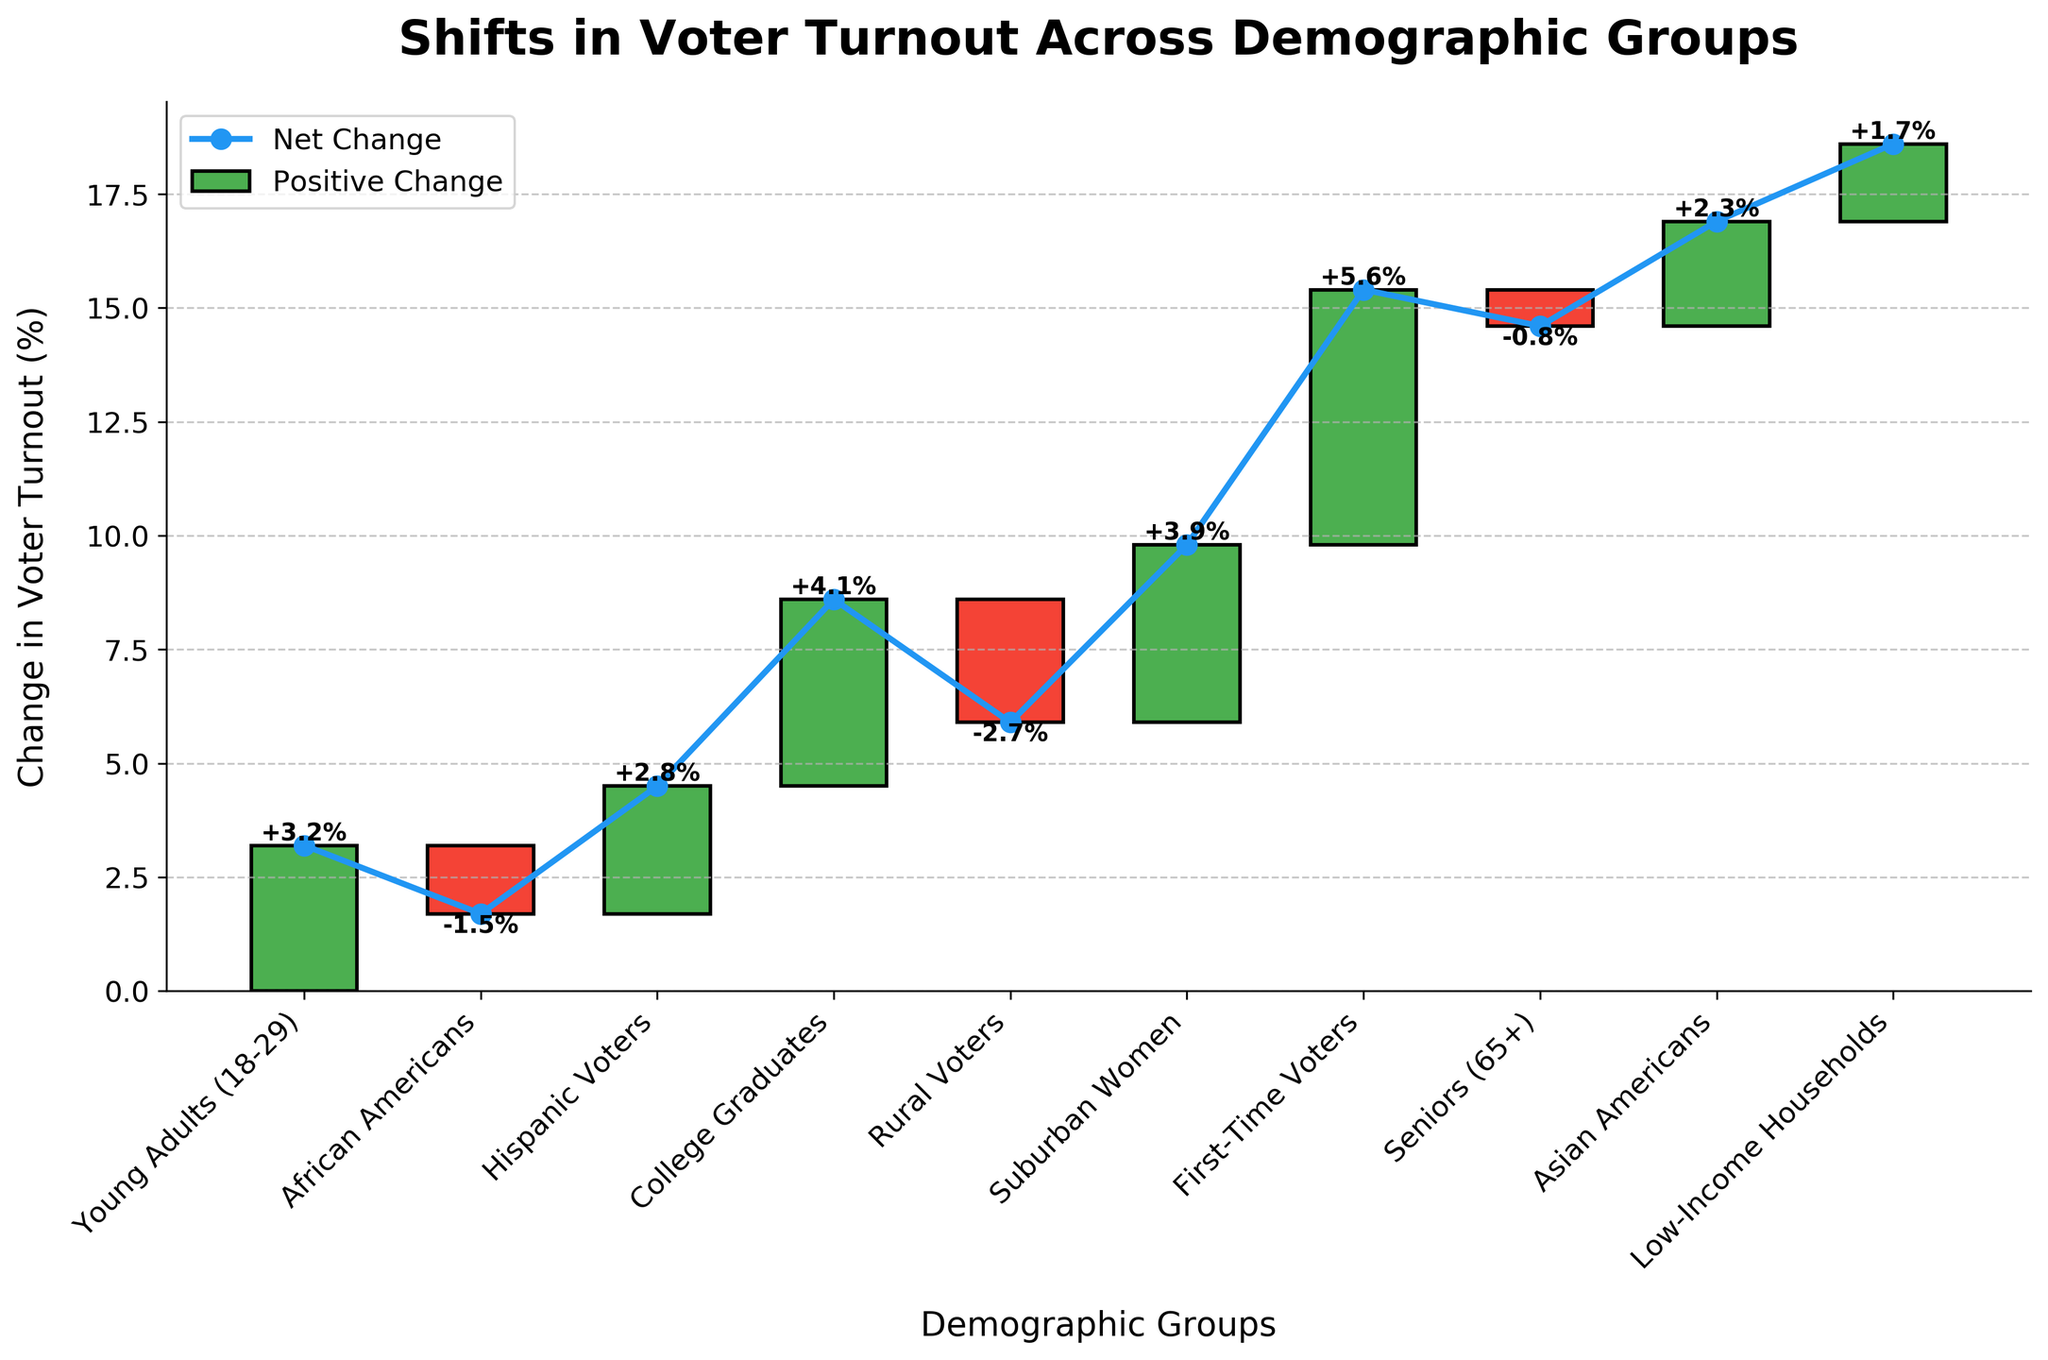What's the title of the plot? The title of the plot is written at the top, giving a clear description of the chart's content.
Answer: Shifts in Voter Turnout Across Demographic Groups How many demographic groups are displayed in the figure? Each bar in the chart represents a demographic group, allowing us to count the total number of categories.
Answer: 10 Which demographic group saw the largest increase in voter turnout? By examining the heights of the bars and their values, we can identify the group with the highest positive change. First-Time Voters has the tallest bar.
Answer: First-Time Voters (+5.6%) Which demographic group experienced the smallest decline in voter turnout? We need to look at the bars that represent a decline (red bars) and identify the smallest one. Seniors (65+) is the group with the smallest decline at -0.8%.
Answer: Seniors (65+) (-0.8%) What's the net change in voter turnout for Suburban Women? Suburban Women's change is explicitly shown on the bar with a value.
Answer: +3.9% How do the turnout changes for Hispanic Voters and Asian Americans compare? We compare the changes directly by looking at their bars and values. Hispanic Voters are +2.8% and Asian Americans are +2.3%, making Hispanics' increase slightly higher.
Answer: Hispanic Voters increased more than Asian Americans What is the combined change in voter turnout for African Americans and Rural Voters? By summing the changes for African Americans (-1.5%) and Rural Voters (-2.7%), we get the combined impact.
Answer: -4.2% Which demographic groups have a positive change in voter turnout? Any bar with a positive change is shaded green. We simply list all groups with green bars.
Answer: Young Adults, Hispanic Voters, College Graduates, Suburban Women, First-Time Voters, Asian Americans, Low-Income Households What's the average voter turnout change across all demographic groups? Adding all changes and dividing by the number of groups: (3.2 - 1.5 + 2.8 + 4.1 - 2.7 + 3.9 + 5.6 - 0.8 + 2.3 + 1.7) / 10 = 1.86.
Answer: +1.86% How do the positive changes cumulatively compare to the negative ones? Sum of positive changes: 3.2 + 2.8 + 4.1 + 3.9 + 5.6 + 2.3 + 1.7 = 23.6. Sum of negative changes: -1.5 - 2.7 - 0.8 = -5.0. Comparison shows positive changes (23.6) are significantly higher than negative changes (-5.0).
Answer: Positive changes are higher 